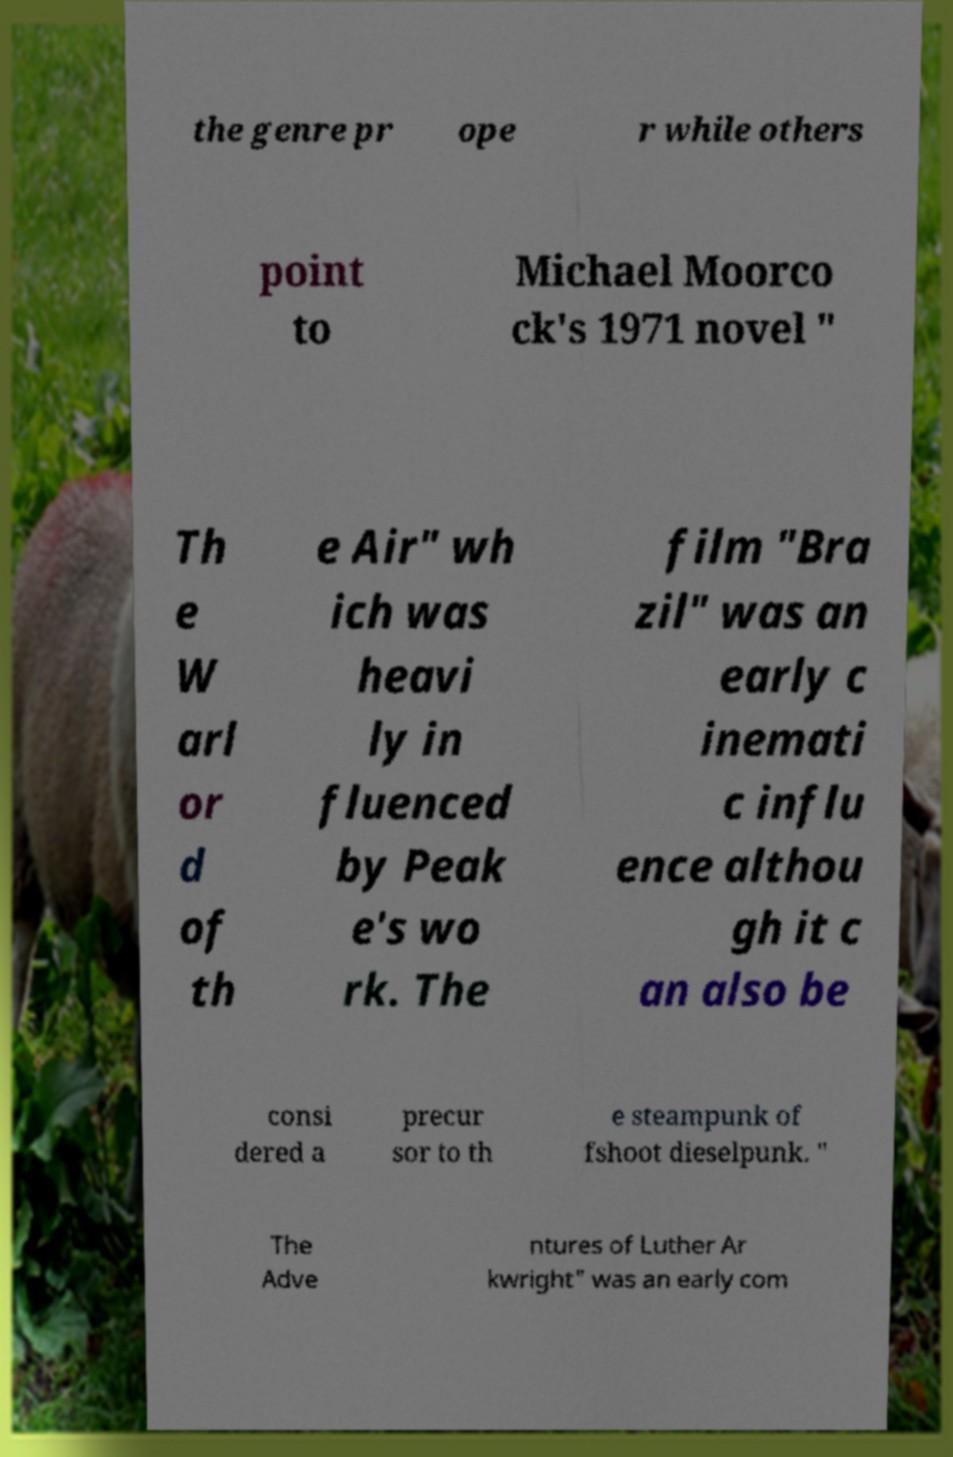I need the written content from this picture converted into text. Can you do that? the genre pr ope r while others point to Michael Moorco ck's 1971 novel " Th e W arl or d of th e Air" wh ich was heavi ly in fluenced by Peak e's wo rk. The film "Bra zil" was an early c inemati c influ ence althou gh it c an also be consi dered a precur sor to th e steampunk of fshoot dieselpunk. " The Adve ntures of Luther Ar kwright" was an early com 